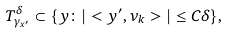Convert formula to latex. <formula><loc_0><loc_0><loc_500><loc_500>T ^ { \delta } _ { \gamma _ { x ^ { \prime } } } \subset \{ y \colon | < y ^ { \prime } , \nu _ { k } > | \leq C \delta \} ,</formula> 